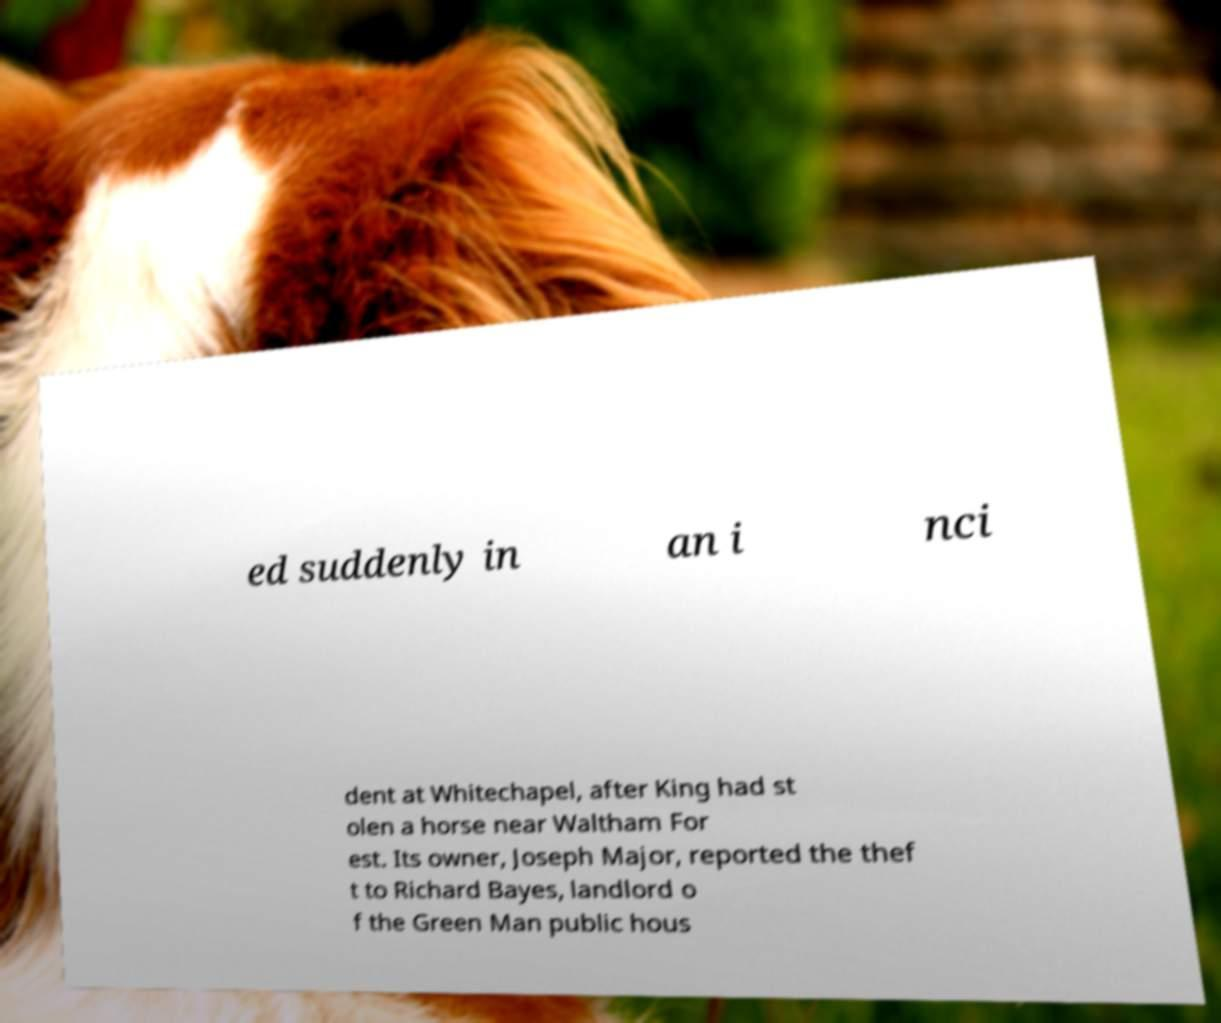Please read and relay the text visible in this image. What does it say? ed suddenly in an i nci dent at Whitechapel, after King had st olen a horse near Waltham For est. Its owner, Joseph Major, reported the thef t to Richard Bayes, landlord o f the Green Man public hous 